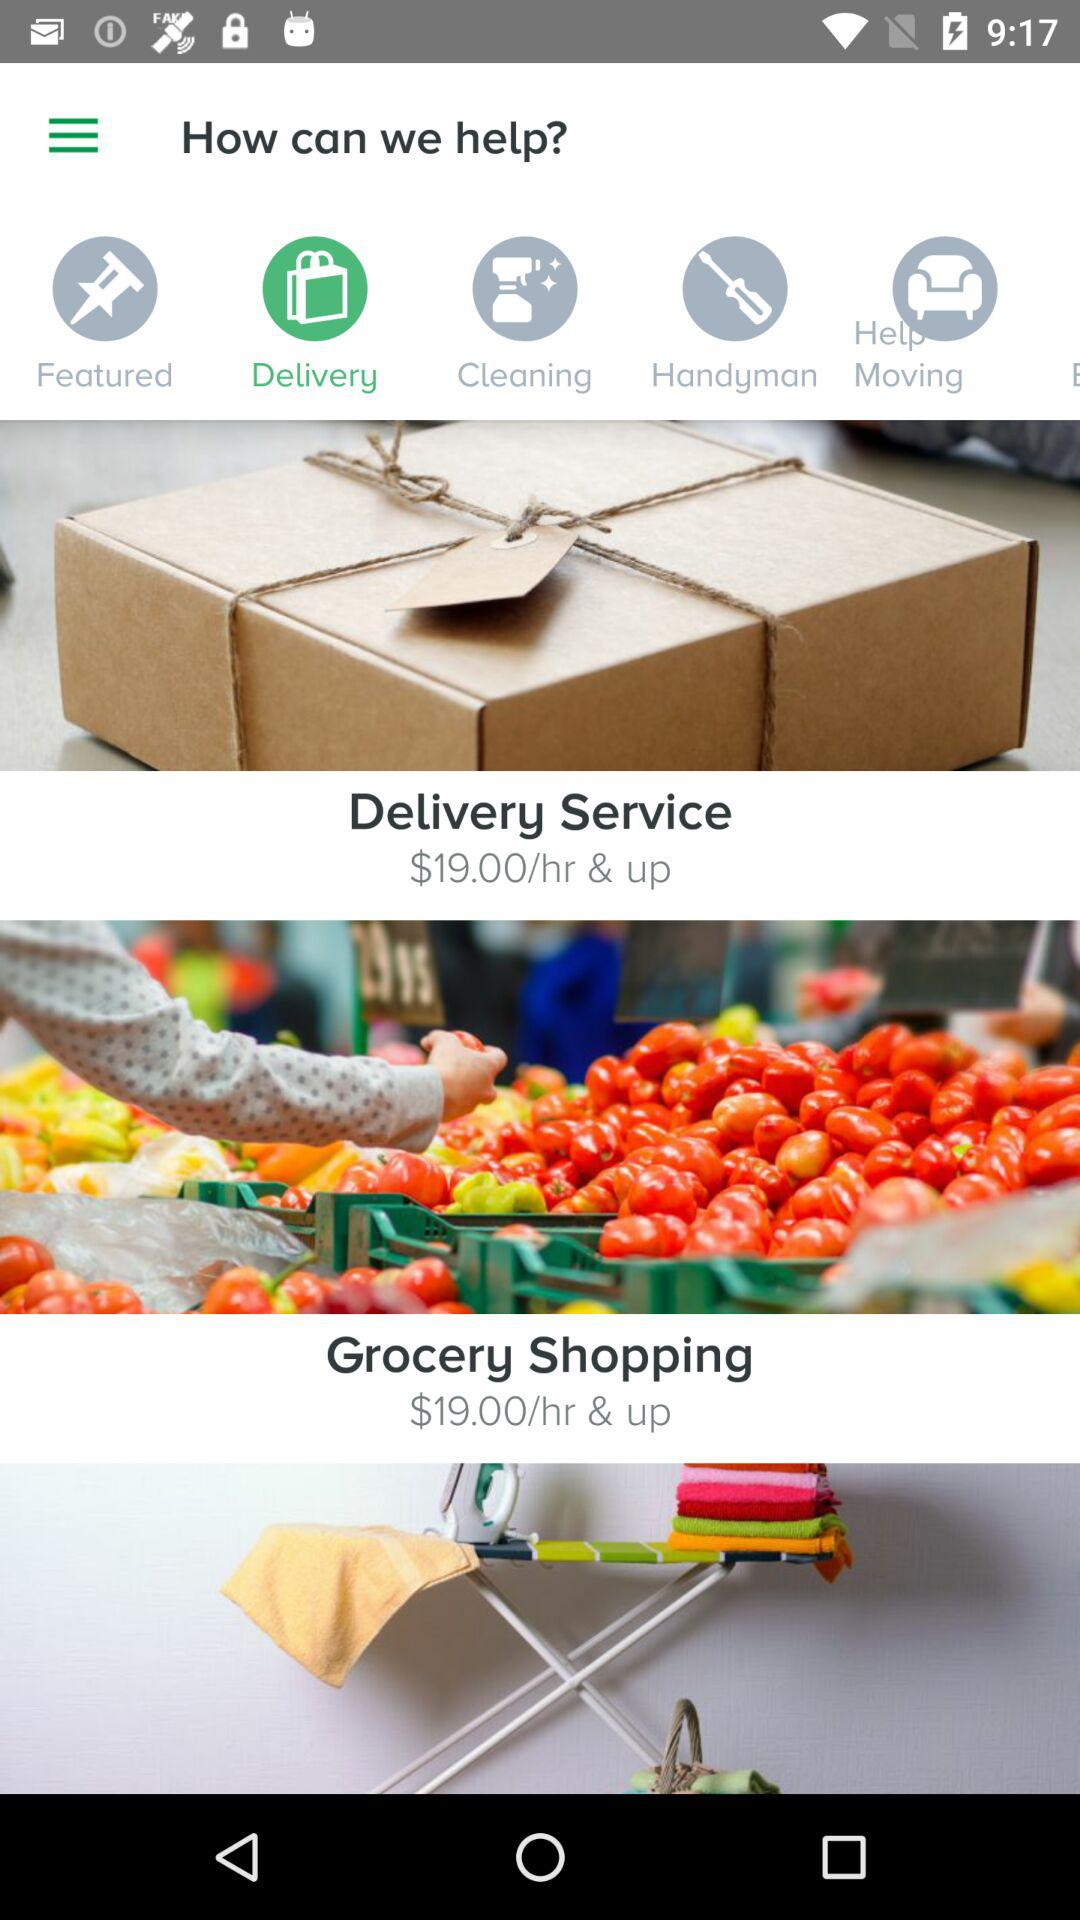Which tab is selected? The selected tab is "Delivery". 